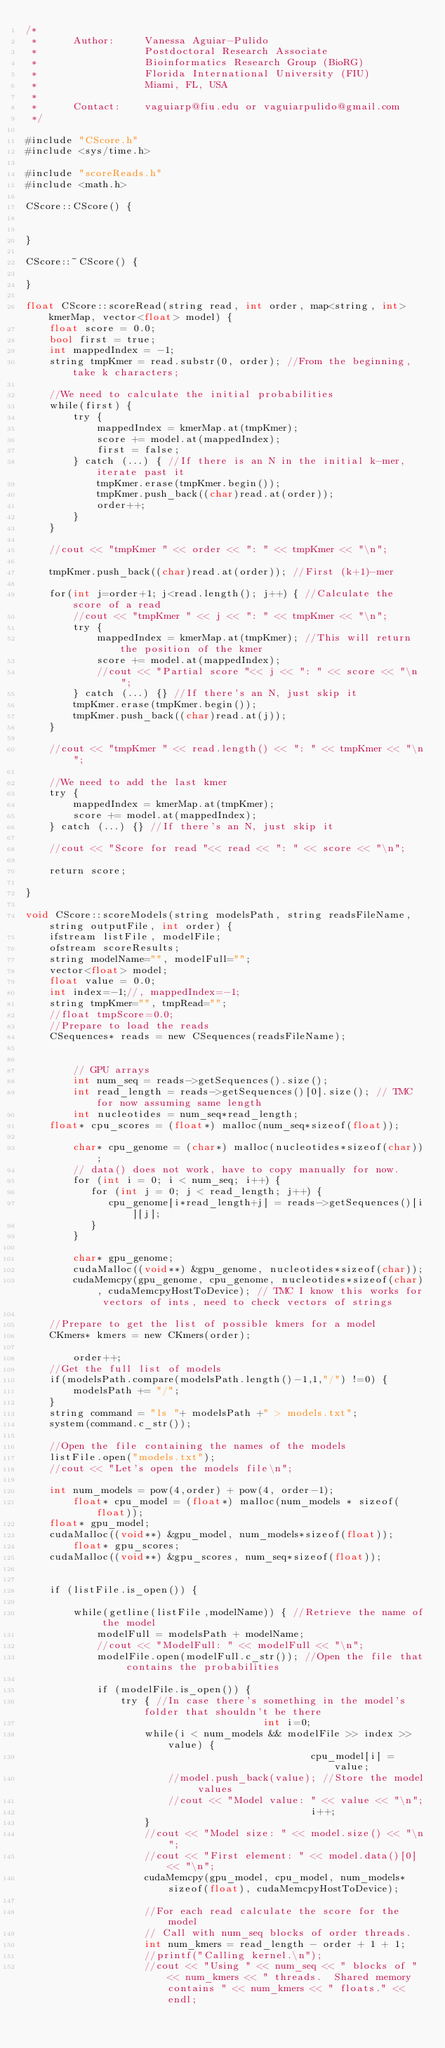Convert code to text. <code><loc_0><loc_0><loc_500><loc_500><_Cuda_>/*
 *      Author: 	Vanessa Aguiar-Pulido
 *      			Postdoctoral Research Associate
 *      			Bioinformatics Research Group (BioRG)
 *      			Florida International University (FIU)
 *      			Miami, FL, USA
 *
 *     	Contact: 	vaguiarp@fiu.edu or vaguiarpulido@gmail.com
 */

#include "CScore.h"
#include <sys/time.h>

#include "scoreReads.h"
#include <math.h>

CScore::CScore() {


}

CScore::~CScore() {

}

float CScore::scoreRead(string read, int order, map<string, int> kmerMap, vector<float> model) {
	float score = 0.0;
	bool first = true;
	int mappedIndex = -1;
	string tmpKmer = read.substr(0, order); //From the beginning, take k characters;

	//We need to calculate the initial probabilities
	while(first) {
		try {
			mappedIndex = kmerMap.at(tmpKmer);
			score += model.at(mappedIndex);
			first = false;
		} catch (...) { //If there is an N in the initial k-mer, iterate past it
			tmpKmer.erase(tmpKmer.begin());
			tmpKmer.push_back((char)read.at(order));
			order++;
		}
	}

	//cout << "tmpKmer " << order << ": " << tmpKmer << "\n";

	tmpKmer.push_back((char)read.at(order)); //First (k+1)-mer

	for(int j=order+1; j<read.length(); j++) { //Calculate the score of a read
		//cout << "tmpKmer " << j << ": " << tmpKmer << "\n";
		try {
			mappedIndex = kmerMap.at(tmpKmer); //This will return the position of the kmer
			score += model.at(mappedIndex);
			//cout << "Partial score "<< j << ": " << score << "\n";
		} catch (...) {} //If there's an N, just skip it
		tmpKmer.erase(tmpKmer.begin());
		tmpKmer.push_back((char)read.at(j));
	}

	//cout << "tmpKmer " << read.length() << ": " << tmpKmer << "\n";

	//We need to add the last kmer
	try {
		mappedIndex = kmerMap.at(tmpKmer);
		score += model.at(mappedIndex);
	} catch (...) {} //If there's an N, just skip it

	//cout << "Score for read "<< read << ": " << score << "\n";

	return score;

}

void CScore::scoreModels(string modelsPath, string readsFileName, string outputFile, int order) {
	ifstream listFile, modelFile;
	ofstream scoreResults;
	string modelName="", modelFull="";
	vector<float> model;
	float value = 0.0;
	int index=-1;//, mappedIndex=-1;
	string tmpKmer="", tmpRead="";
	//float tmpScore=0.0;
	//Prepare to load the reads
	CSequences* reads = new CSequences(readsFileName);


        // GPU arrays
        int num_seq = reads->getSequences().size();
        int read_length = reads->getSequences()[0].size(); // TMC for now assuming same length
        int nucleotides = num_seq*read_length;
	float* cpu_scores = (float*) malloc(num_seq*sizeof(float));
 
        char* cpu_genome = (char*) malloc(nucleotides*sizeof(char));
        // data() does not work, have to copy manually for now.
        for (int i = 0; i < num_seq; i++) {
           for (int j = 0; j < read_length; j++) {
              cpu_genome[i*read_length+j] = reads->getSequences()[i][j];
           }
        }

        char* gpu_genome;
        cudaMalloc((void**) &gpu_genome, nucleotides*sizeof(char));
        cudaMemcpy(gpu_genome, cpu_genome, nucleotides*sizeof(char), cudaMemcpyHostToDevice); // TMC I know this works for vectors of ints, need to check vectors of strings

	//Prepare to get the list of possible kmers for a model
	CKmers* kmers = new CKmers(order);

        order++;
	//Get the full list of models
	if(modelsPath.compare(modelsPath.length()-1,1,"/") !=0) {
		modelsPath += "/";
	}
	string command = "ls "+ modelsPath +" > models.txt";
	system(command.c_str());

	//Open the file containing the names of the models
	listFile.open("models.txt");
	//cout << "Let's open the models file\n";

	int num_models = pow(4,order) + pow(4, order-1);
        float* cpu_model = (float*) malloc(num_models * sizeof(float));
	float* gpu_model;
	cudaMalloc((void**) &gpu_model, num_models*sizeof(float));
        float* gpu_scores;
	cudaMalloc((void**) &gpu_scores, num_seq*sizeof(float));
      

	if (listFile.is_open()) {

		while(getline(listFile,modelName)) { //Retrieve the name of the model
			modelFull = modelsPath + modelName;
			//cout << "ModelFull: " << modelFull << "\n";
			modelFile.open(modelFull.c_str()); //Open the file that contains the probabilities

			if (modelFile.is_open()) {
				try { //In case there's something in the model's folder that shouldn't be there
                                        int i=0;
					while(i < num_models && modelFile >> index >> value) {
                                                cpu_model[i] = value;
						//model.push_back(value); //Store the model values
						//cout << "Model value: " << value << "\n";
                                                i++;
					}
					//cout << "Model size: " << model.size() << "\n";
					//cout << "First element: " << model.data()[0] << "\n";
					cudaMemcpy(gpu_model, cpu_model, num_models*sizeof(float), cudaMemcpyHostToDevice);

					//For each read calculate the score for the model
					// Call with num_seq blocks of order threads.
					int num_kmers = read_length - order + 1 + 1;
					//printf("Calling kernel.\n");
					//cout << "Using " << num_seq << " blocks of " << num_kmers << " threads.  Shared memory contains " << num_kmers << " floats." << endl;</code> 